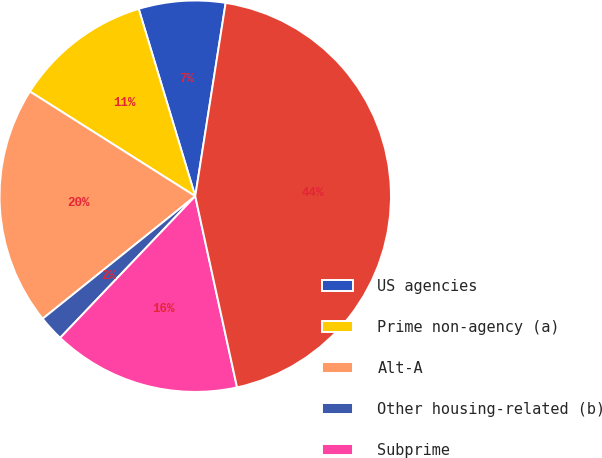Convert chart to OTSL. <chart><loc_0><loc_0><loc_500><loc_500><pie_chart><fcel>US agencies<fcel>Prime non-agency (a)<fcel>Alt-A<fcel>Other housing-related (b)<fcel>Subprime<fcel>Total<nl><fcel>7.15%<fcel>11.35%<fcel>19.75%<fcel>2.11%<fcel>15.55%<fcel>44.09%<nl></chart> 